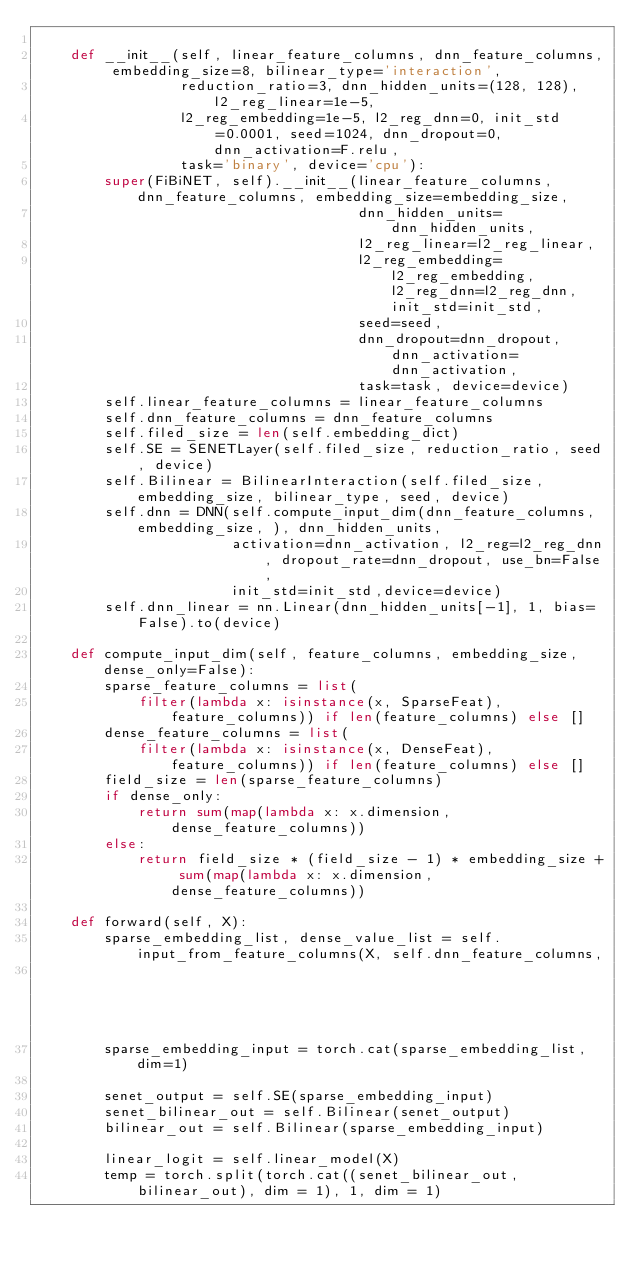Convert code to text. <code><loc_0><loc_0><loc_500><loc_500><_Python_>
    def __init__(self, linear_feature_columns, dnn_feature_columns, embedding_size=8, bilinear_type='interaction',
                 reduction_ratio=3, dnn_hidden_units=(128, 128), l2_reg_linear=1e-5,
                 l2_reg_embedding=1e-5, l2_reg_dnn=0, init_std=0.0001, seed=1024, dnn_dropout=0, dnn_activation=F.relu,
                 task='binary', device='cpu'):
        super(FiBiNET, self).__init__(linear_feature_columns, dnn_feature_columns, embedding_size=embedding_size,
                                      dnn_hidden_units=dnn_hidden_units,
                                      l2_reg_linear=l2_reg_linear,
                                      l2_reg_embedding=l2_reg_embedding, l2_reg_dnn=l2_reg_dnn, init_std=init_std,
                                      seed=seed,
                                      dnn_dropout=dnn_dropout, dnn_activation=dnn_activation,
                                      task=task, device=device)
        self.linear_feature_columns = linear_feature_columns
        self.dnn_feature_columns = dnn_feature_columns
        self.filed_size = len(self.embedding_dict)
        self.SE = SENETLayer(self.filed_size, reduction_ratio, seed, device)
        self.Bilinear = BilinearInteraction(self.filed_size,embedding_size, bilinear_type, seed, device)
        self.dnn = DNN(self.compute_input_dim(dnn_feature_columns, embedding_size, ), dnn_hidden_units,
                       activation=dnn_activation, l2_reg=l2_reg_dnn, dropout_rate=dnn_dropout, use_bn=False,
                       init_std=init_std,device=device)
        self.dnn_linear = nn.Linear(dnn_hidden_units[-1], 1, bias=False).to(device)

    def compute_input_dim(self, feature_columns, embedding_size, dense_only=False):
        sparse_feature_columns = list(
            filter(lambda x: isinstance(x, SparseFeat), feature_columns)) if len(feature_columns) else []
        dense_feature_columns = list(
            filter(lambda x: isinstance(x, DenseFeat), feature_columns)) if len(feature_columns) else []
        field_size = len(sparse_feature_columns)
        if dense_only:
            return sum(map(lambda x: x.dimension, dense_feature_columns))
        else:
            return field_size * (field_size - 1) * embedding_size + sum(map(lambda x: x.dimension, dense_feature_columns))

    def forward(self, X):
        sparse_embedding_list, dense_value_list = self.input_from_feature_columns(X, self.dnn_feature_columns,
                                                                                  self.embedding_dict)
        sparse_embedding_input = torch.cat(sparse_embedding_list, dim=1)

        senet_output = self.SE(sparse_embedding_input)
        senet_bilinear_out = self.Bilinear(senet_output)
        bilinear_out = self.Bilinear(sparse_embedding_input)

        linear_logit = self.linear_model(X)
        temp = torch.split(torch.cat((senet_bilinear_out,bilinear_out), dim = 1), 1, dim = 1)</code> 